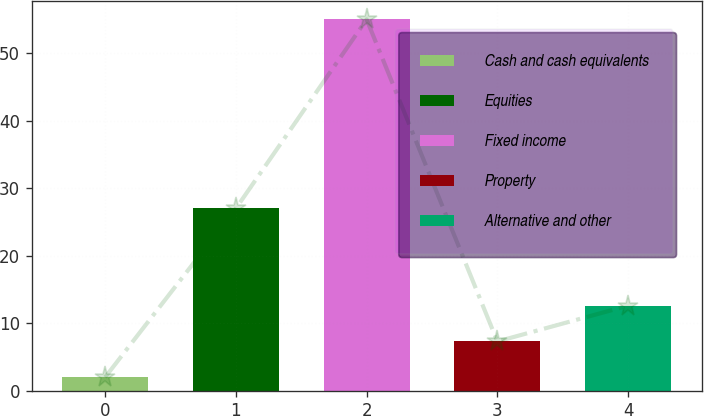Convert chart. <chart><loc_0><loc_0><loc_500><loc_500><bar_chart><fcel>Cash and cash equivalents<fcel>Equities<fcel>Fixed income<fcel>Property<fcel>Alternative and other<nl><fcel>2<fcel>27<fcel>55<fcel>7.3<fcel>12.6<nl></chart> 